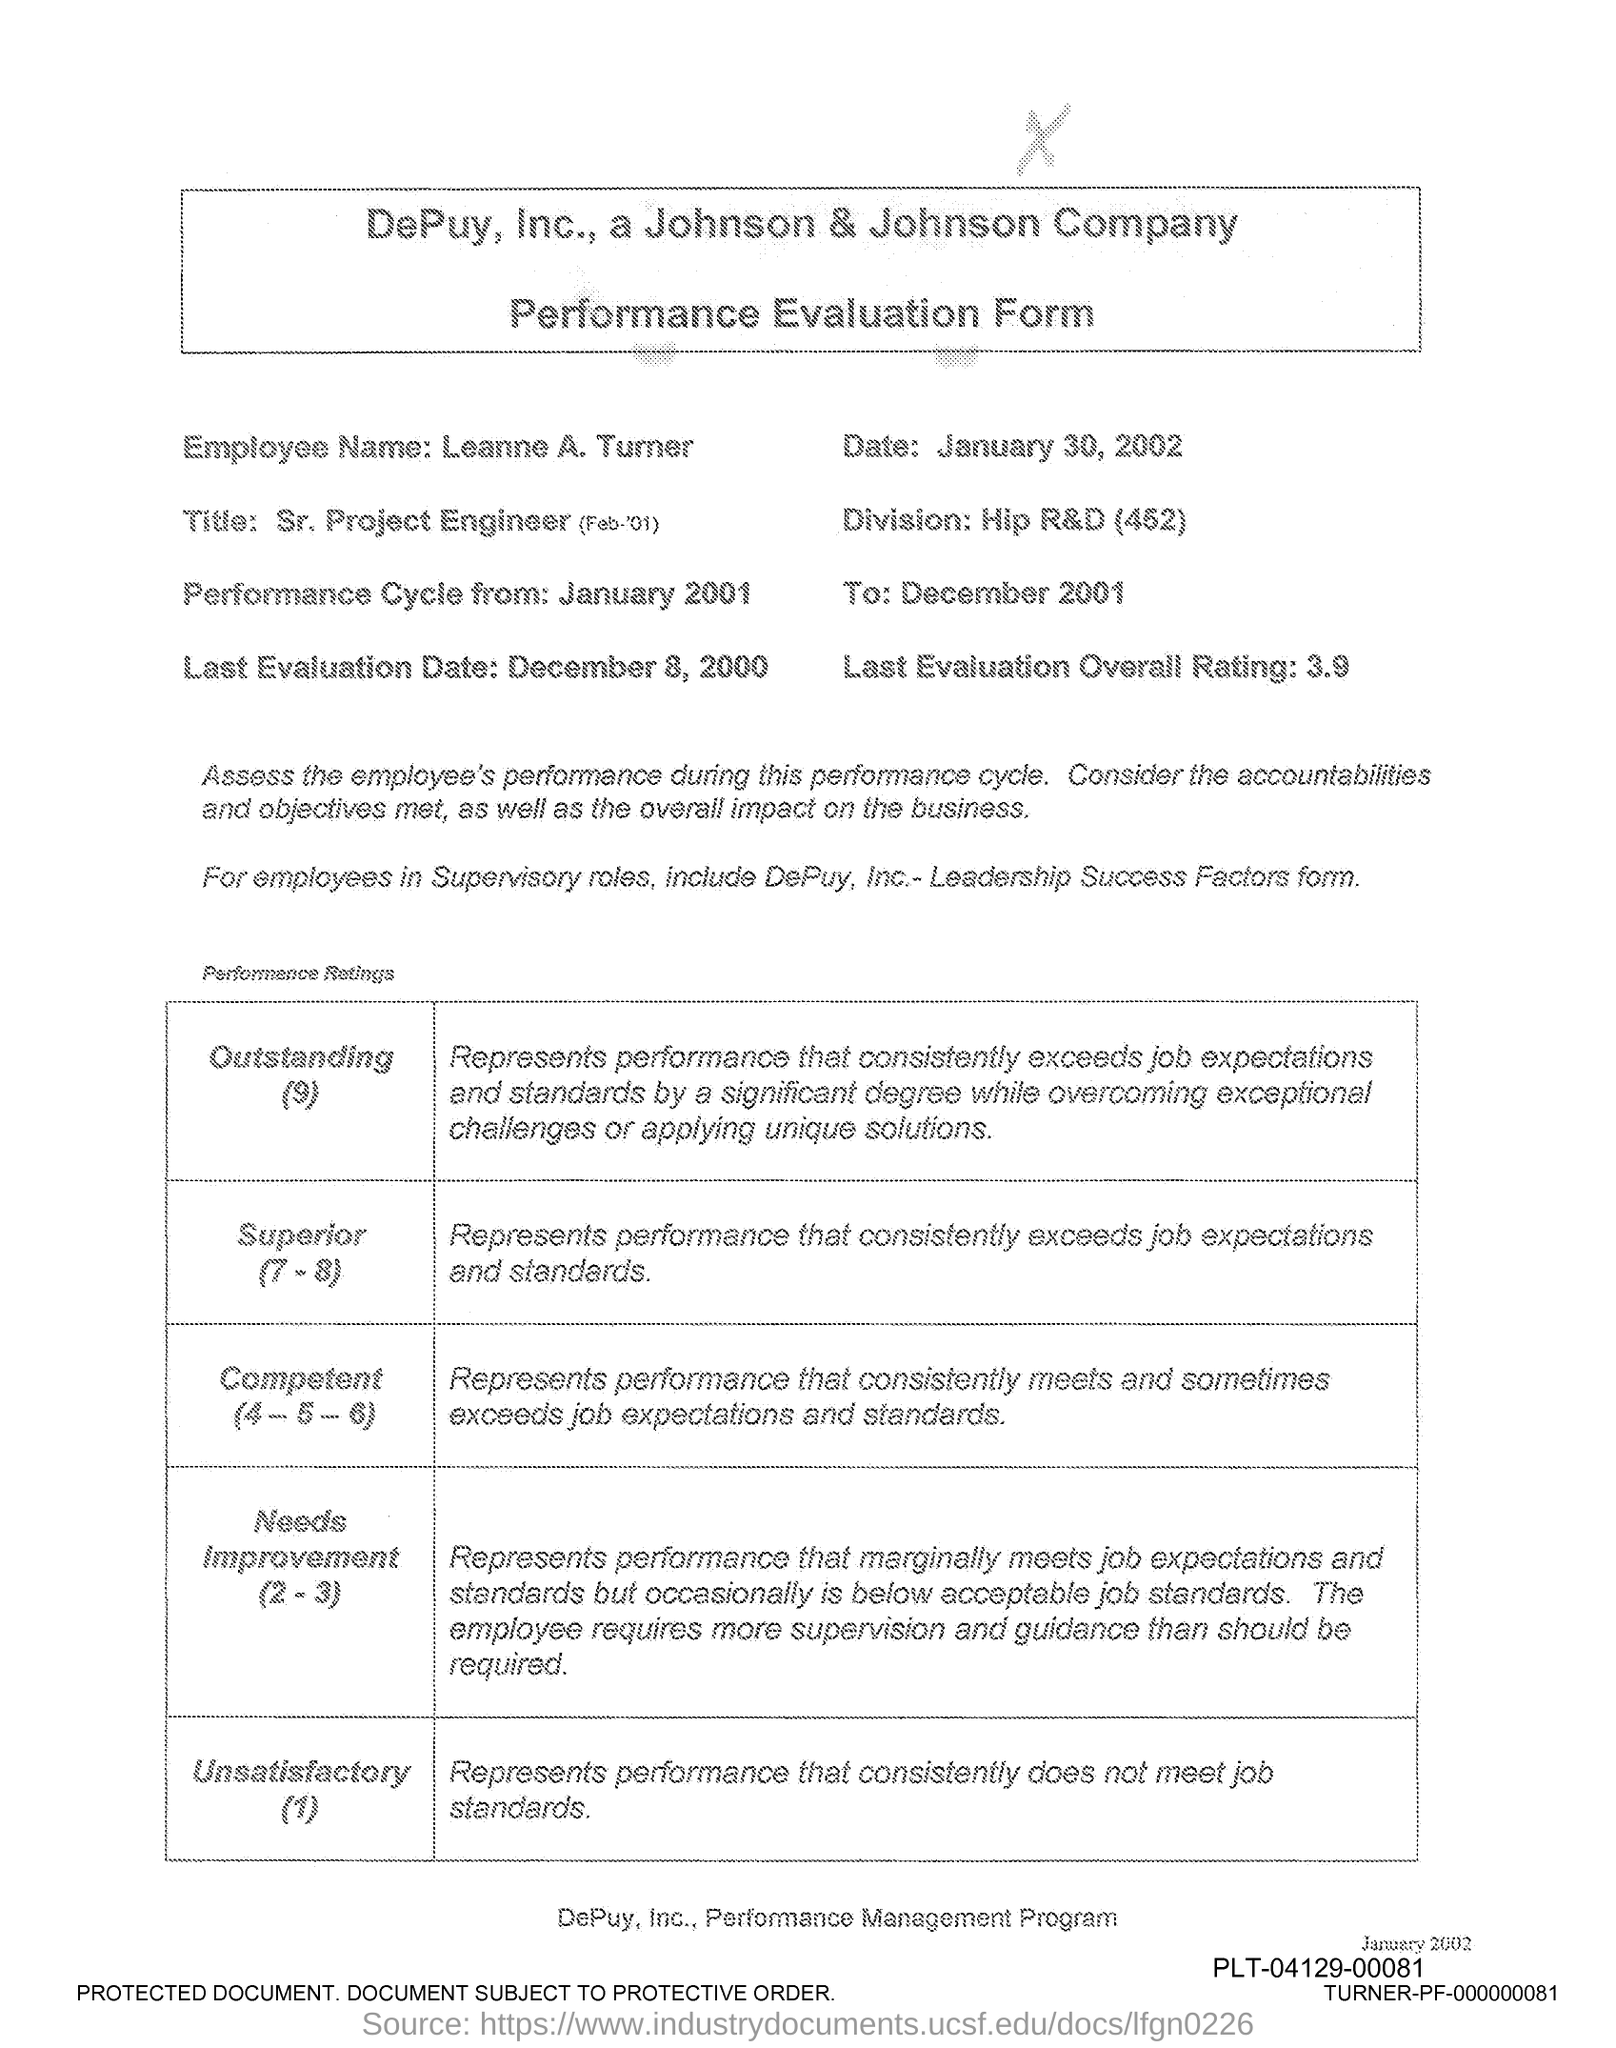What is the Employee Name?
Give a very brief answer. Leanne A. Turner. What is the Date?
Your response must be concise. January 30, 2002. What is the Division?
Your answer should be compact. Hip R&D (452). When is the Perfomance Cycle from?
Your response must be concise. January 2001. When is the Last evaluation Date?
Ensure brevity in your answer.  December 8, 2000. What is the Last evaluation Overall Rating?
Your answer should be compact. 3.9. 